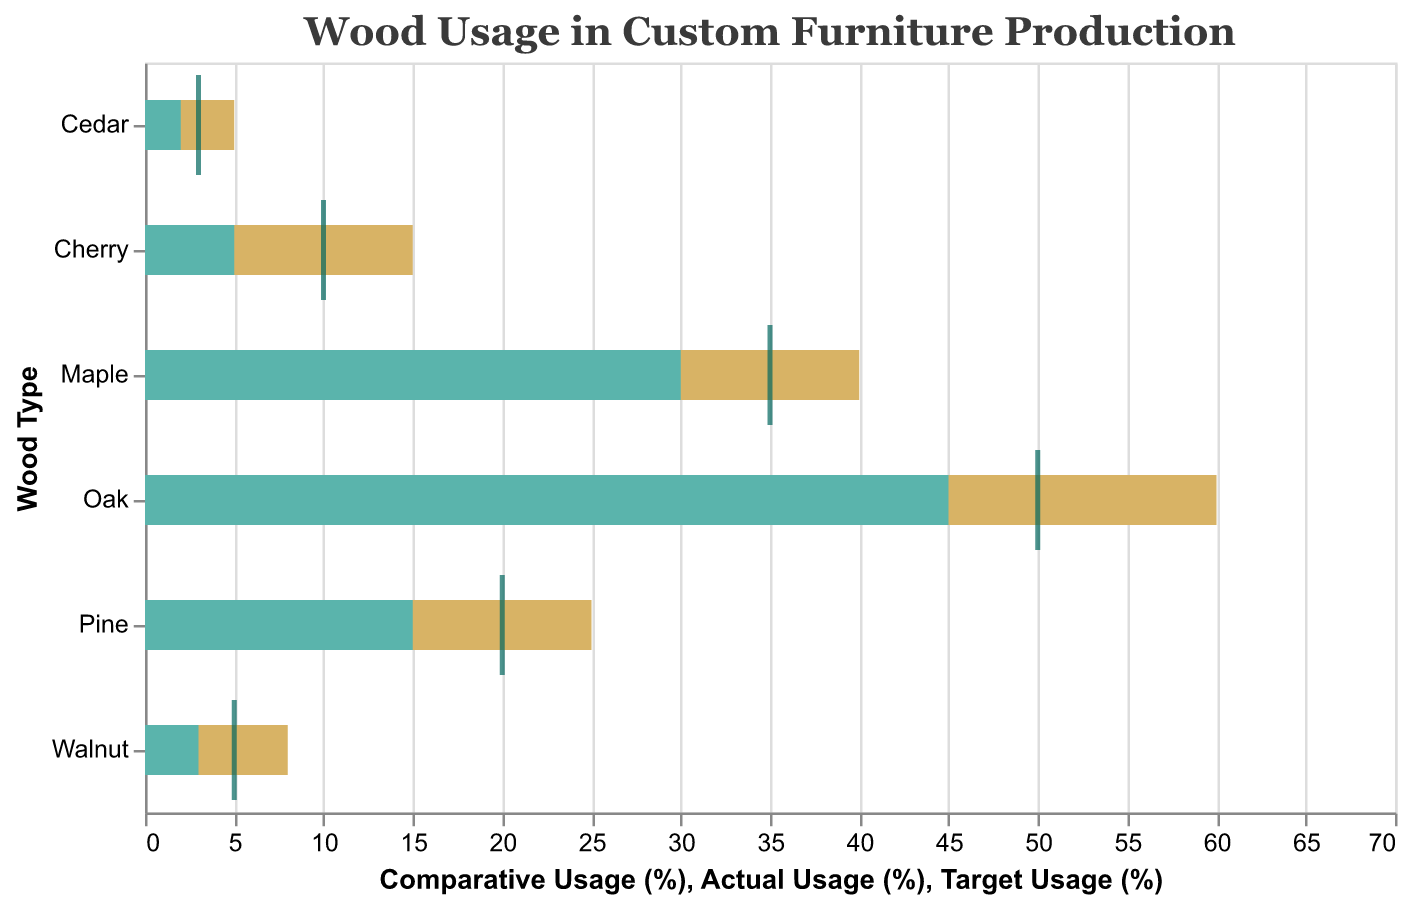What wood type has the highest actual usage percentage in custom furniture production? The actual usage percentages indicated by the inner bars range from 2% to 45%. By visually comparing these inner bars, we notice that Oak has the highest actual usage percentage at 45%.
Answer: Oak What is the target usage percentage for Maple wood? To find the target usage percentage, which is marked by a tick, we look specifically at Maple and see that it has a value of 35%.
Answer: 35% How does Pine's actual usage compare to its target usage? The inner bar represents actual usage and the tick mark indicates the target. Pine's actual usage is 15%, while its target usage is 20%. Comparing 15% to 20%, Pine's actual usage is 5% less than its target.
Answer: 5% less Which wood type has the biggest gap between actual usage and comparative usage, and what is that gap? The gap can be found by subtracting the actual usage from the comparative usage for each wood type. The wood type with the largest gap is Oak, which has a comparative usage of 60% and actual usage of 45%. The gap is 60% - 45% = 15%.
Answer: Oak, 15% What's the average target usage percentage for the given wood types? The target usage percentages are 50%, 35%, 20%, 10%, 5%, and 3%. Adding them together, we get 50 + 35 + 20 + 10 + 5 + 3 = 123. To find the average, we divide by the number of wood types: 123 / 6 = 20.5%.
Answer: 20.5% Which wood type has the smallest difference between its actual usage percentage and its target usage percentage? To find the smallest difference, we calculate the absolute difference between the actual and target usage percentages for each wood type: Oak (5%), Maple (5%), Pine (5%), Cherry (5%), Walnut (2%), Cedar (1%). Cedar has the smallest difference at 1%.
Answer: Cedar Among the hardwoods (Oak, Maple, Cherry, Walnut), which has the closest actual usage to its target usage? For Oak (45% vs. 50%), Maple (30% vs. 35%), Cherry (5% vs. 10%), and Walnut (3% vs. 5%), the differences between actual and target usages respectively are 5%, 5%, 5%, and 2%. Walnut has the closest actual usage to its target usage with a difference of 2%.
Answer: Walnut How does Walnut's comparative usage compare to Cherry's comparative usage? Walnut's comparative usage is 8%, and Cherry's is 15%. Comparing the two, Walnut's comparative usage is 7% less than Cherry's.
Answer: 7% less 